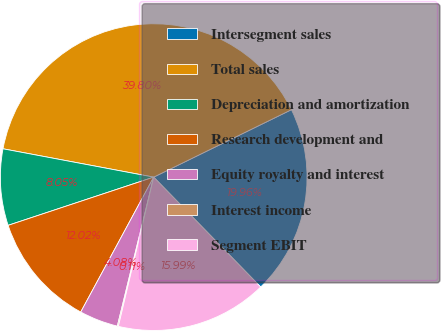Convert chart to OTSL. <chart><loc_0><loc_0><loc_500><loc_500><pie_chart><fcel>Intersegment sales<fcel>Total sales<fcel>Depreciation and amortization<fcel>Research development and<fcel>Equity royalty and interest<fcel>Interest income<fcel>Segment EBIT<nl><fcel>19.96%<fcel>39.8%<fcel>8.05%<fcel>12.02%<fcel>4.08%<fcel>0.11%<fcel>15.99%<nl></chart> 